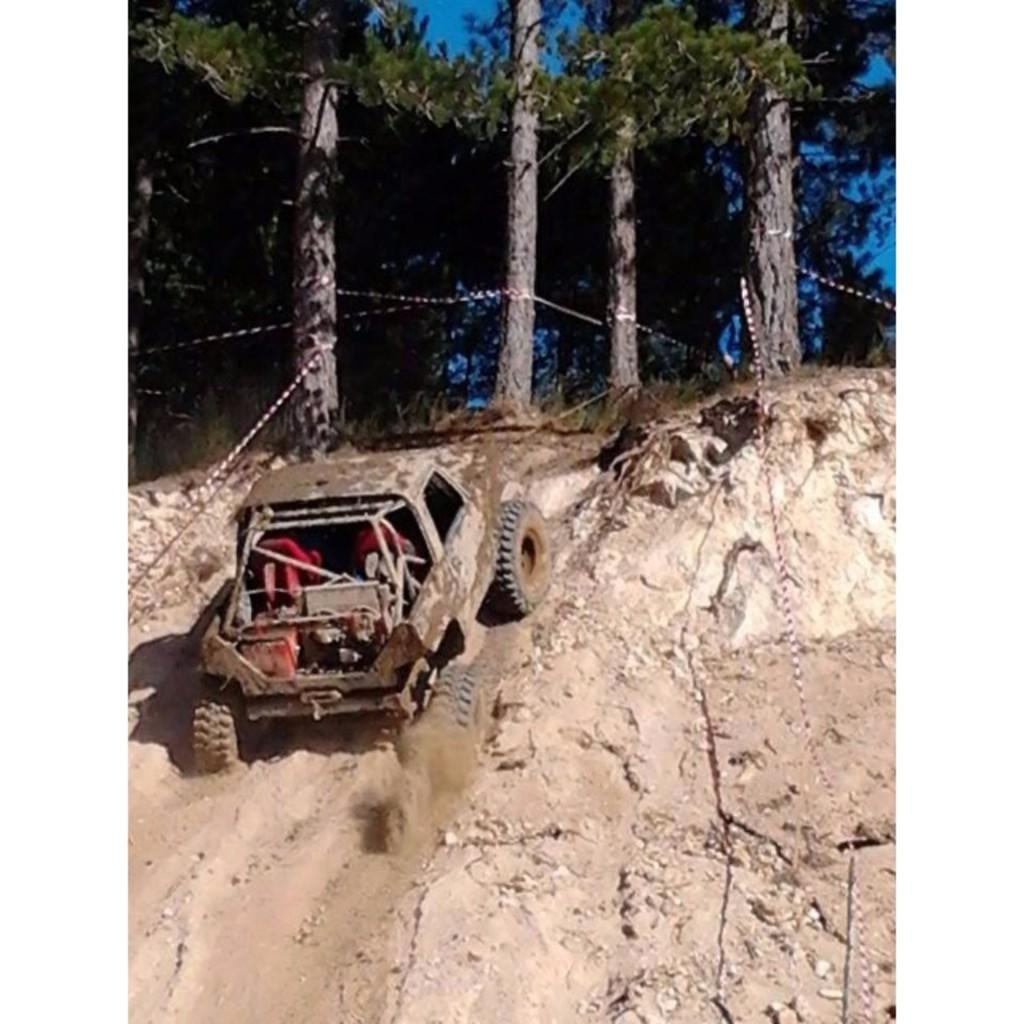What is located on the ground in the image? There is a vehicle on the ground in the image. What can be seen in the background of the image? There are trees and the sky visible in the background of the image. Where is the mitten located in the image? There is no mitten present in the image. What type of rake is being used to clear the leaves in the image? There is no rake or leaves present in the image; it only features a vehicle on the ground and trees and the sky in the background. 